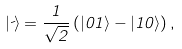<formula> <loc_0><loc_0><loc_500><loc_500>| \psi \rangle = \frac { 1 } { \sqrt { 2 } } \left ( | 0 1 \rangle - | 1 0 \rangle \right ) ,</formula> 